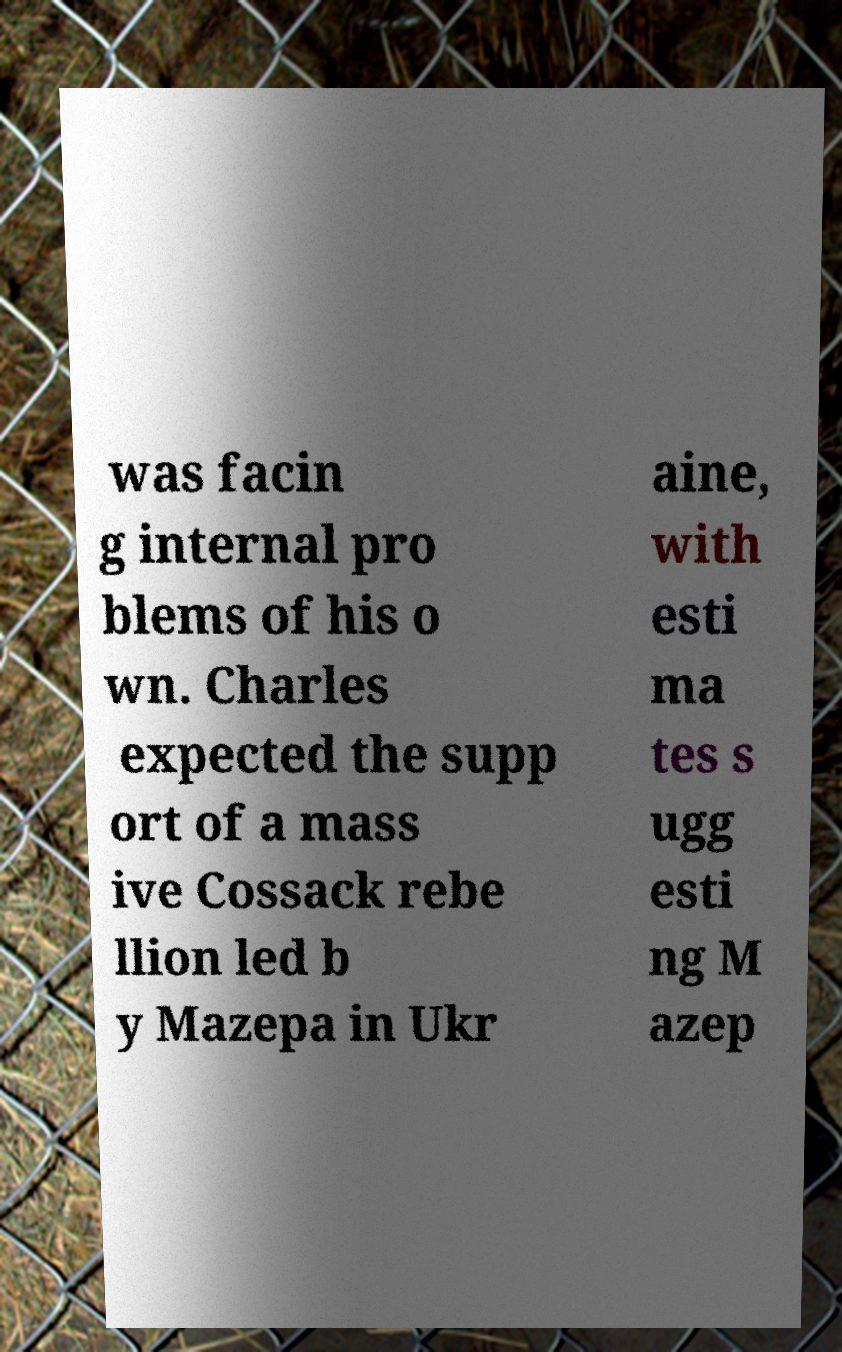What messages or text are displayed in this image? I need them in a readable, typed format. was facin g internal pro blems of his o wn. Charles expected the supp ort of a mass ive Cossack rebe llion led b y Mazepa in Ukr aine, with esti ma tes s ugg esti ng M azep 